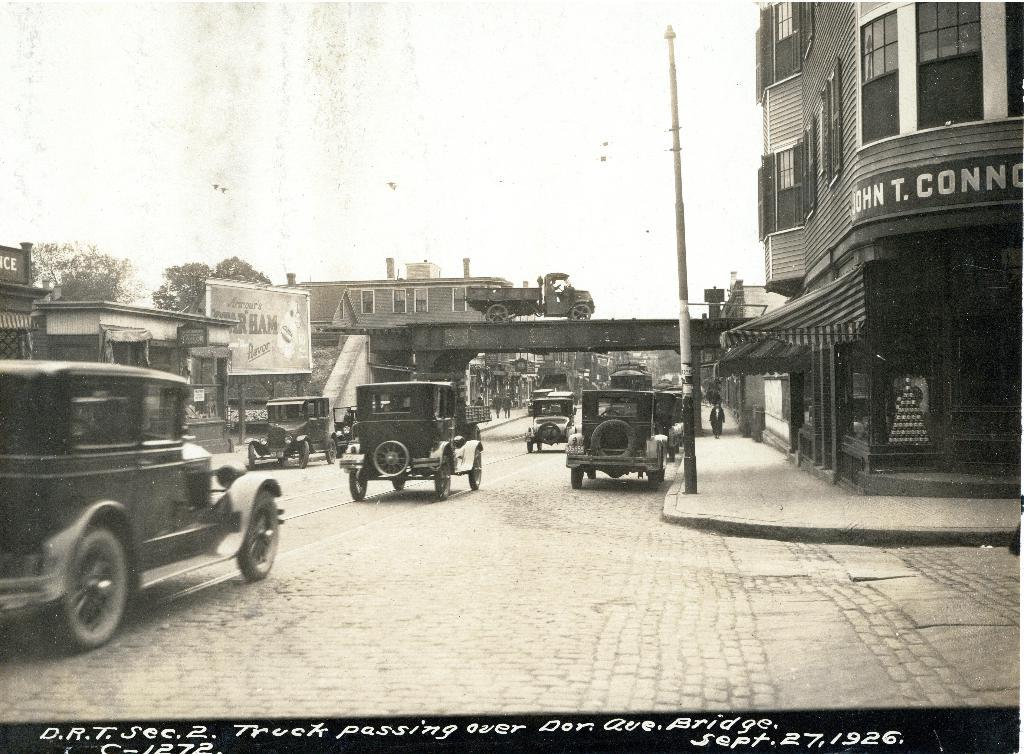What can be seen on the road in the image? There are vehicles on the road in the image. What is visible in the background of the image? There is a bridge, buildings, trees, poles, and the sky visible in the background of the image. What organization is responsible for maintaining the property in the image? There is no specific organization mentioned or implied in the image, and no property is explicitly identified as being maintained. 